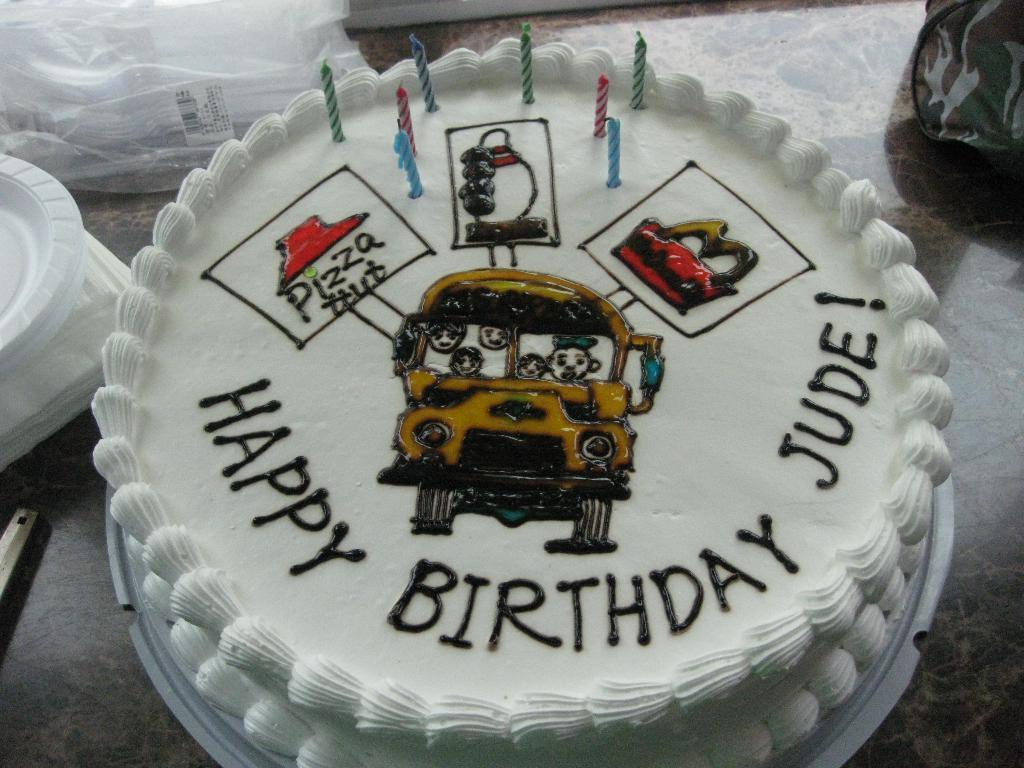Can you describe this image briefly? In this image we can see a cake with candles on it and there are few tissue papers, plates, a cover and few other objects on the surface which looks like a table. 